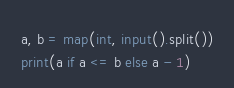Convert code to text. <code><loc_0><loc_0><loc_500><loc_500><_Python_>a, b = map(int, input().split())
print(a if a <= b else a - 1)</code> 